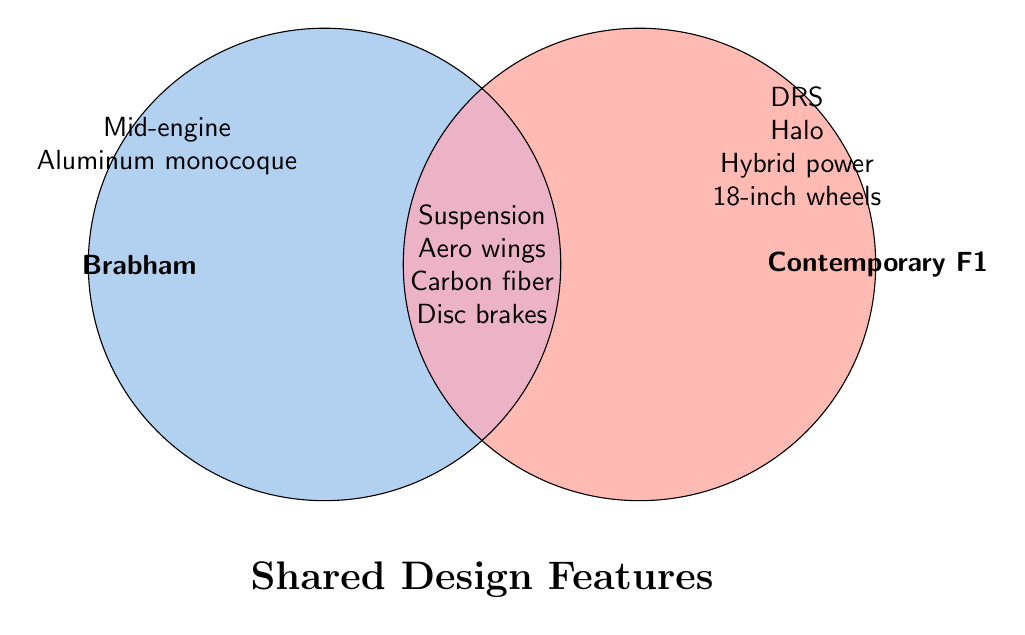Which design features are unique to Contemporary F1 cars? Features listed in the Contemporary F1 circle, but not in the intersection or Brabham circle, are unique to Contemporary F1 cars. These features are DRS, Halo, Hybrid power, and 18-inch wheels.
Answer: DRS, Halo, Hybrid power, 18-inch wheels Which design features are shared between Brabham and Contemporary F1 cars? Features listed in the intersection of the two circles are shared between Brabham and Contemporary F1 cars.
Answer: Suspension, Aero wings, Carbon fiber, Disc brakes What design features are only found in Brabham cars? Features listed in the Brabham circle, but not in the intersection or Contemporary F1 circle, are unique to Brabham cars. These features are Mid-engine and Aluminum monocoque.
Answer: Mid-engine, Aluminum monocoque How many design features does the Contemporary F1 category have in total, including shared features? Count both the unique features of Contemporary F1 cars and the shared features. There are 4 unique features (DRS, Halo, Hybrid power, 18-inch wheels) and 4 shared features (Suspension, Aero wings, Carbon fiber, Disc brakes), totaling 8.
Answer: 8 Are disc brakes used in both Brabham and Contemporary F1 cars? Disc brakes are listed in the intersection of the two circles, indicating they are a shared feature.
Answer: Yes Which category has a feature related to hybrid power? Look for the feature "Hybrid power unit" in the Venn diagram. It's in the Contemporary F1 circle.
Answer: Contemporary F1 Which category uses aerodynamic wings? Aerodynamic wings are listed in the intersection, indicating they are used by both categories.
Answer: Both Do Brabham cars use an aluminum monocoque chassis? The feature "Aluminum monocoque" is listed in the Brabham circle, confirming it is used.
Answer: Yes 